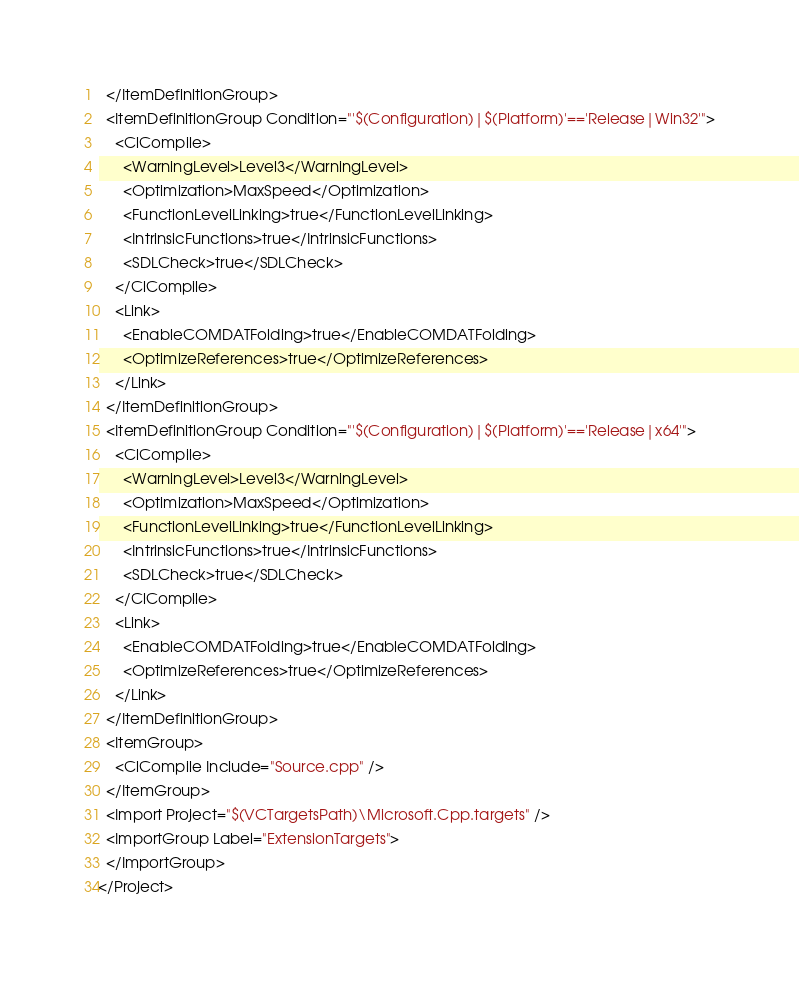<code> <loc_0><loc_0><loc_500><loc_500><_XML_>  </ItemDefinitionGroup>
  <ItemDefinitionGroup Condition="'$(Configuration)|$(Platform)'=='Release|Win32'">
    <ClCompile>
      <WarningLevel>Level3</WarningLevel>
      <Optimization>MaxSpeed</Optimization>
      <FunctionLevelLinking>true</FunctionLevelLinking>
      <IntrinsicFunctions>true</IntrinsicFunctions>
      <SDLCheck>true</SDLCheck>
    </ClCompile>
    <Link>
      <EnableCOMDATFolding>true</EnableCOMDATFolding>
      <OptimizeReferences>true</OptimizeReferences>
    </Link>
  </ItemDefinitionGroup>
  <ItemDefinitionGroup Condition="'$(Configuration)|$(Platform)'=='Release|x64'">
    <ClCompile>
      <WarningLevel>Level3</WarningLevel>
      <Optimization>MaxSpeed</Optimization>
      <FunctionLevelLinking>true</FunctionLevelLinking>
      <IntrinsicFunctions>true</IntrinsicFunctions>
      <SDLCheck>true</SDLCheck>
    </ClCompile>
    <Link>
      <EnableCOMDATFolding>true</EnableCOMDATFolding>
      <OptimizeReferences>true</OptimizeReferences>
    </Link>
  </ItemDefinitionGroup>
  <ItemGroup>
    <ClCompile Include="Source.cpp" />
  </ItemGroup>
  <Import Project="$(VCTargetsPath)\Microsoft.Cpp.targets" />
  <ImportGroup Label="ExtensionTargets">
  </ImportGroup>
</Project></code> 